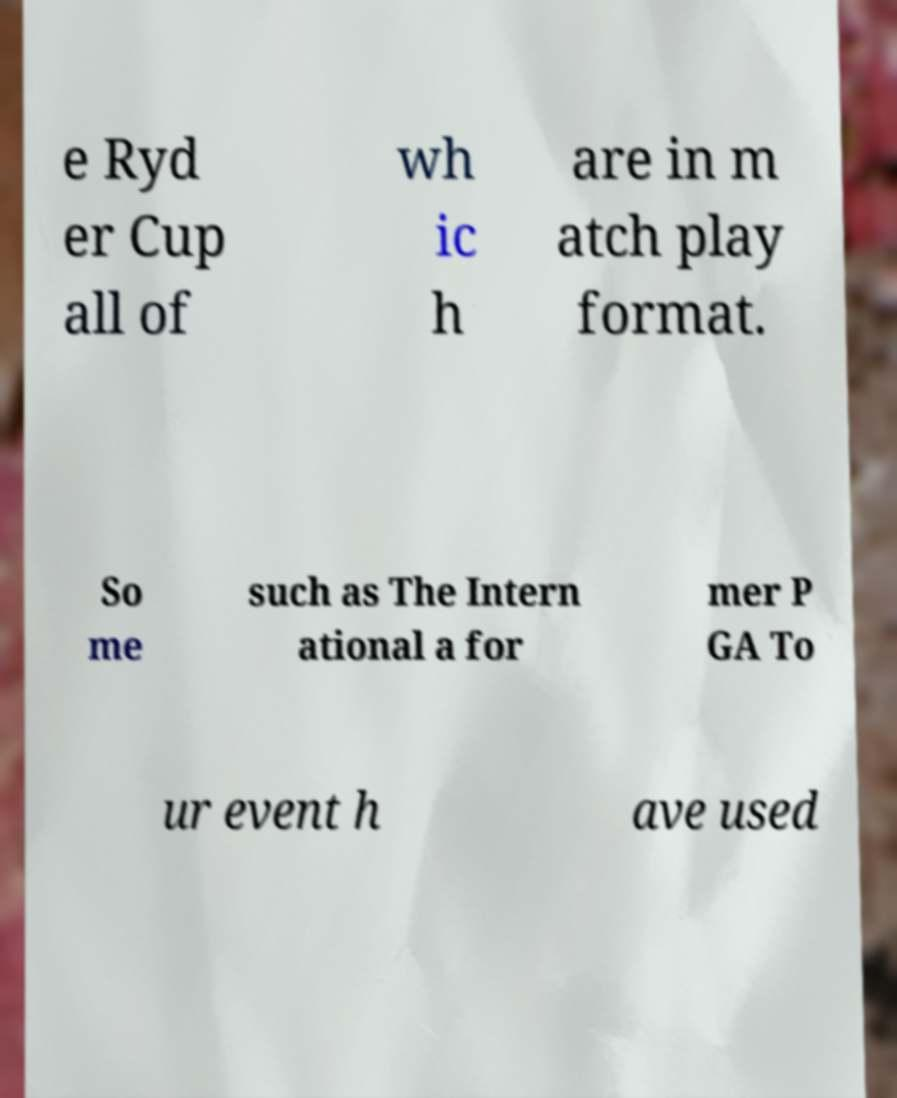Could you extract and type out the text from this image? e Ryd er Cup all of wh ic h are in m atch play format. So me such as The Intern ational a for mer P GA To ur event h ave used 